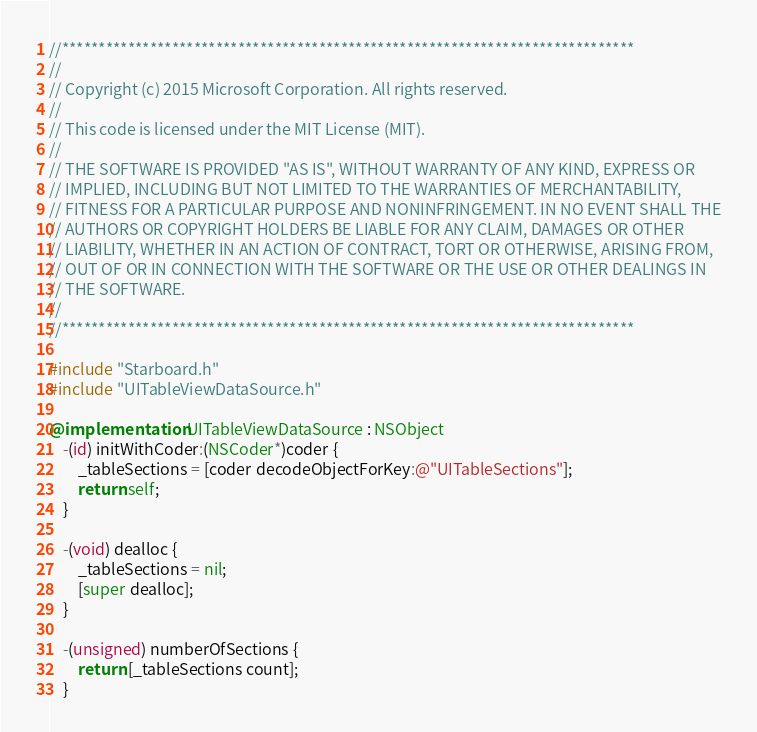<code> <loc_0><loc_0><loc_500><loc_500><_ObjectiveC_>//******************************************************************************
//
// Copyright (c) 2015 Microsoft Corporation. All rights reserved.
//
// This code is licensed under the MIT License (MIT).
//
// THE SOFTWARE IS PROVIDED "AS IS", WITHOUT WARRANTY OF ANY KIND, EXPRESS OR
// IMPLIED, INCLUDING BUT NOT LIMITED TO THE WARRANTIES OF MERCHANTABILITY,
// FITNESS FOR A PARTICULAR PURPOSE AND NONINFRINGEMENT. IN NO EVENT SHALL THE
// AUTHORS OR COPYRIGHT HOLDERS BE LIABLE FOR ANY CLAIM, DAMAGES OR OTHER
// LIABILITY, WHETHER IN AN ACTION OF CONTRACT, TORT OR OTHERWISE, ARISING FROM,
// OUT OF OR IN CONNECTION WITH THE SOFTWARE OR THE USE OR OTHER DEALINGS IN
// THE SOFTWARE.
//
//******************************************************************************

#include "Starboard.h"
#include "UITableViewDataSource.h"

@implementation UITableViewDataSource : NSObject
    -(id) initWithCoder:(NSCoder*)coder {
        _tableSections = [coder decodeObjectForKey:@"UITableSections"];
        return self;
    }

    -(void) dealloc {
        _tableSections = nil;
        [super dealloc];
    }

    -(unsigned) numberOfSections {
        return [_tableSections count];
    }
</code> 